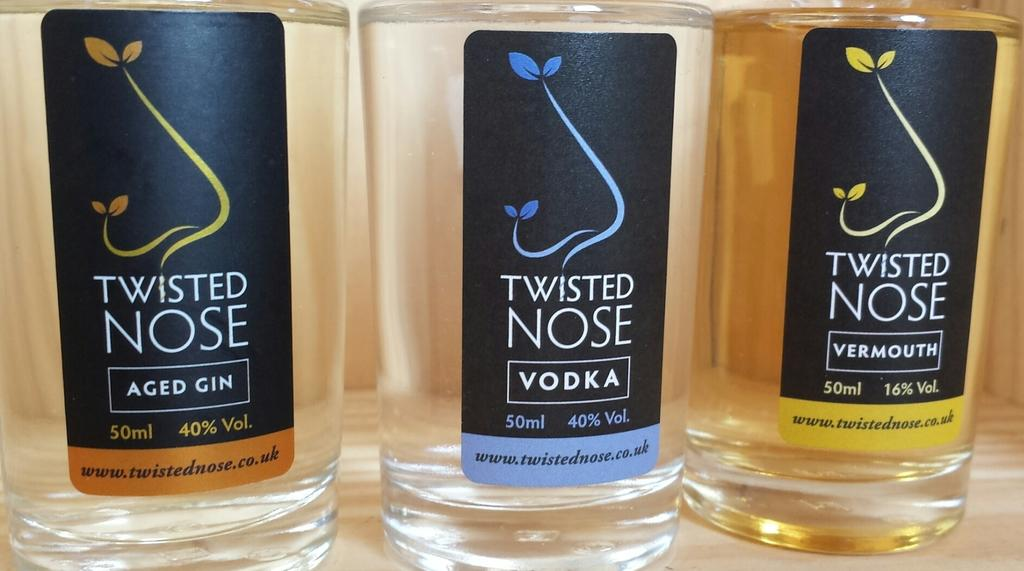<image>
Relay a brief, clear account of the picture shown. twisted nose vodka bottles standing next to one another 